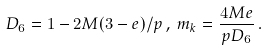Convert formula to latex. <formula><loc_0><loc_0><loc_500><loc_500>D _ { 6 } = 1 - 2 M ( 3 - e ) / p \, , \, m _ { k } = \frac { 4 M e } { p D _ { 6 } } \, .</formula> 